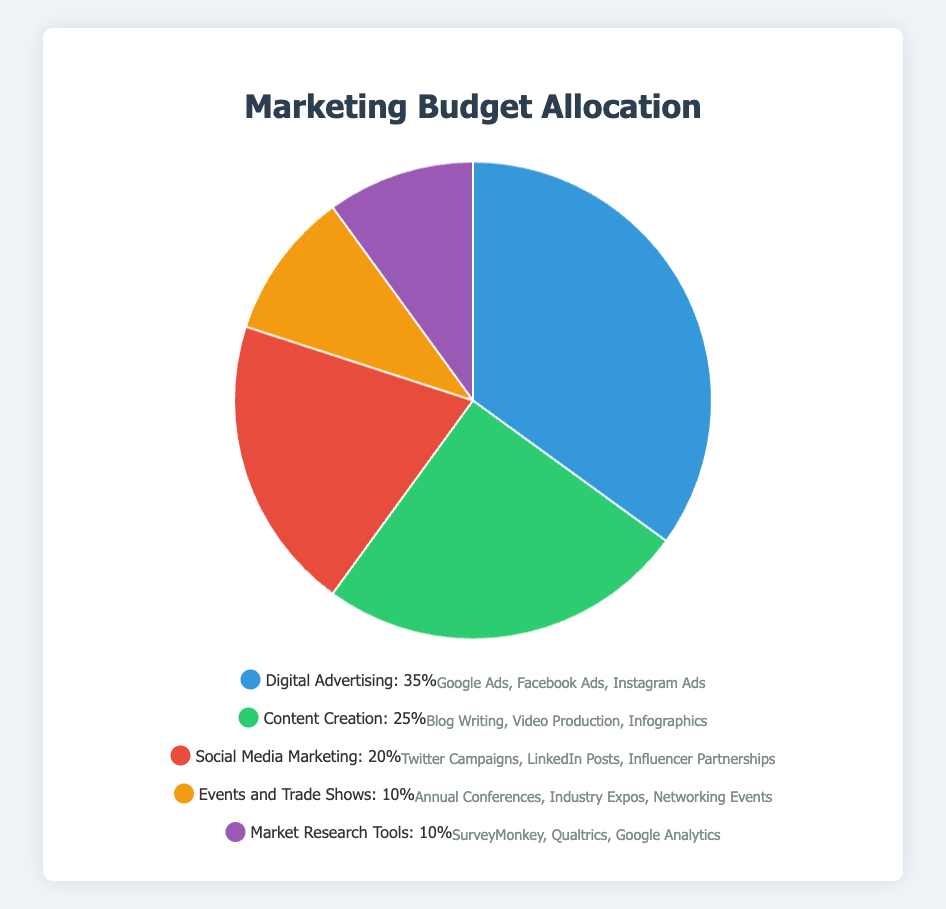What percentage of the marketing budget is allocated to Digital Advertising? Refer to the figure: Digital Advertising is labeled as 35% in the pie chart.
Answer: 35% What is the combined budget percentage for Events and Trade Shows and Market Research Tools? Add the budget percentages for both categories. Events and Trade Shows: 10%, Market Research Tools: 10%. Calculation: 10% + 10% = 20%
Answer: 20% Which has a higher budget allocation, Content Creation or Social Media Marketing? Compare the budget percentages. Content Creation: 25%, Social Media Marketing: 20%.
Answer: Content Creation What is the difference in budget allocation between Digital Advertising and Events and Trade Shows? Subtract the budget of Events and Trade Shows from Digital Advertising. Digital Advertising: 35%, Events and Trade Shows: 10%. Calculation: 35% - 10% = 25%
Answer: 25% How many categories have a budget allocation of 10%? Count the relevant categories in the figure. Events and Trade Shows: 10%, Market Research Tools: 10%. There are 2 categories.
Answer: 2 What color represents Social Media Marketing in the pie chart? Refer to the colors used in the chart. Social Media Marketing is represented by red.
Answer: Red What is the average budget allocation percentage across all categories? Sum all budget percentages and divide by the number of categories. Calculation: (35% + 25% + 20% + 10% + 10%) / 5 = 100% / 5 = 20%
Answer: 20% List the entities included under Market Research Tools. Refer to the legend detailing the entities for each category. Market Research Tools includes: SurveyMonkey, Qualtrics, and Google Analytics.
Answer: SurveyMonkey, Qualtrics, Google Analytics Which category has the smallest budget allocation and what is the allocated percentage? Identify the smallest percentage in the figure. Events and Trade Shows and Market Research Tools both have the smallest allocation at 10%.
Answer: Events and Trade Shows, Market Research Tools: 10% If the budget for Social Media Marketing increased by 5%, what would the new percentage be? Add the increase to the current budget percentage. Social Media Marketing: 20%, Increase: 5%. Calculation: 20% + 5% = 25%
Answer: 25% 